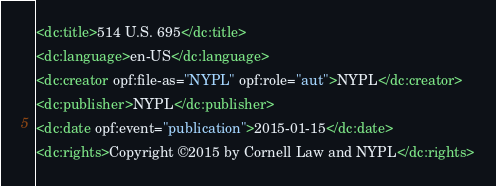Convert code to text. <code><loc_0><loc_0><loc_500><loc_500><_XML_><dc:title>514 U.S. 695</dc:title>
<dc:language>en-US</dc:language>
<dc:creator opf:file-as="NYPL" opf:role="aut">NYPL</dc:creator>
<dc:publisher>NYPL</dc:publisher>
<dc:date opf:event="publication">2015-01-15</dc:date>
<dc:rights>Copyright ©2015 by Cornell Law and NYPL</dc:rights></code> 